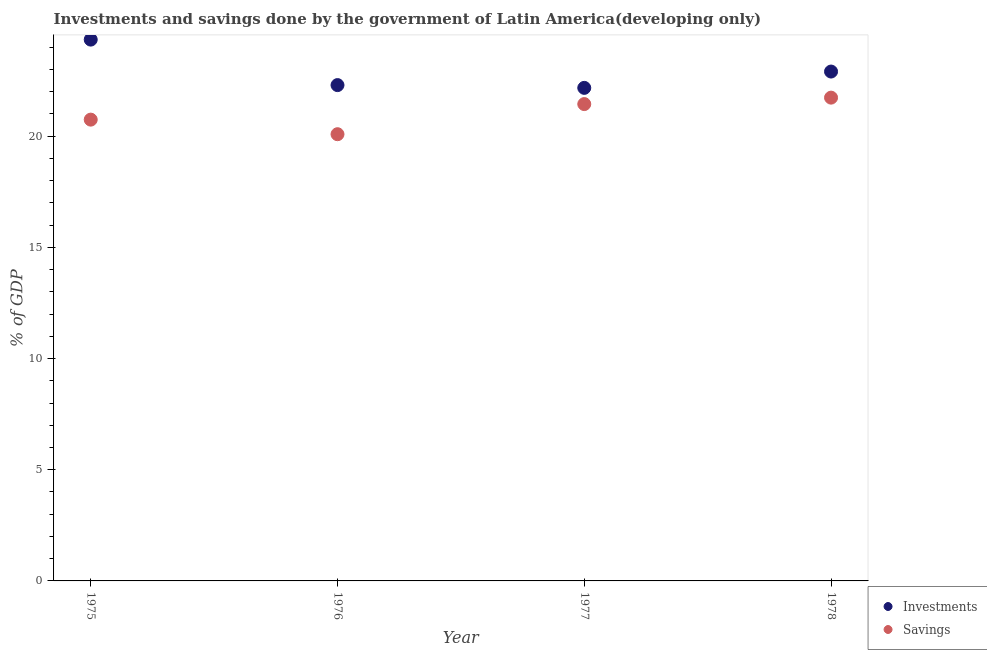Is the number of dotlines equal to the number of legend labels?
Ensure brevity in your answer.  Yes. What is the savings of government in 1978?
Offer a very short reply. 21.73. Across all years, what is the maximum investments of government?
Provide a succinct answer. 24.34. Across all years, what is the minimum savings of government?
Provide a short and direct response. 20.09. In which year was the savings of government maximum?
Your response must be concise. 1978. What is the total investments of government in the graph?
Offer a very short reply. 91.71. What is the difference between the investments of government in 1975 and that in 1977?
Your answer should be compact. 2.17. What is the difference between the savings of government in 1978 and the investments of government in 1976?
Keep it short and to the point. -0.56. What is the average savings of government per year?
Offer a terse response. 21. In the year 1975, what is the difference between the savings of government and investments of government?
Your answer should be very brief. -3.6. In how many years, is the savings of government greater than 1 %?
Offer a very short reply. 4. What is the ratio of the investments of government in 1976 to that in 1977?
Offer a very short reply. 1.01. Is the investments of government in 1975 less than that in 1976?
Keep it short and to the point. No. Is the difference between the savings of government in 1975 and 1976 greater than the difference between the investments of government in 1975 and 1976?
Provide a short and direct response. No. What is the difference between the highest and the second highest savings of government?
Offer a terse response. 0.29. What is the difference between the highest and the lowest savings of government?
Your response must be concise. 1.64. In how many years, is the investments of government greater than the average investments of government taken over all years?
Offer a terse response. 1. Is the sum of the investments of government in 1976 and 1977 greater than the maximum savings of government across all years?
Provide a succinct answer. Yes. Does the savings of government monotonically increase over the years?
Provide a short and direct response. No. What is the difference between two consecutive major ticks on the Y-axis?
Your response must be concise. 5. Does the graph contain grids?
Provide a short and direct response. No. Where does the legend appear in the graph?
Offer a very short reply. Bottom right. How many legend labels are there?
Provide a short and direct response. 2. How are the legend labels stacked?
Keep it short and to the point. Vertical. What is the title of the graph?
Give a very brief answer. Investments and savings done by the government of Latin America(developing only). Does "Investment in Transport" appear as one of the legend labels in the graph?
Your answer should be very brief. No. What is the label or title of the Y-axis?
Offer a terse response. % of GDP. What is the % of GDP in Investments in 1975?
Your answer should be very brief. 24.34. What is the % of GDP of Savings in 1975?
Make the answer very short. 20.74. What is the % of GDP in Investments in 1976?
Your answer should be compact. 22.3. What is the % of GDP of Savings in 1976?
Keep it short and to the point. 20.09. What is the % of GDP of Investments in 1977?
Offer a terse response. 22.17. What is the % of GDP of Savings in 1977?
Provide a short and direct response. 21.44. What is the % of GDP of Investments in 1978?
Provide a succinct answer. 22.9. What is the % of GDP of Savings in 1978?
Keep it short and to the point. 21.73. Across all years, what is the maximum % of GDP of Investments?
Your answer should be very brief. 24.34. Across all years, what is the maximum % of GDP of Savings?
Your response must be concise. 21.73. Across all years, what is the minimum % of GDP of Investments?
Give a very brief answer. 22.17. Across all years, what is the minimum % of GDP in Savings?
Your answer should be very brief. 20.09. What is the total % of GDP in Investments in the graph?
Provide a short and direct response. 91.71. What is the total % of GDP of Savings in the graph?
Your answer should be very brief. 84. What is the difference between the % of GDP of Investments in 1975 and that in 1976?
Keep it short and to the point. 2.05. What is the difference between the % of GDP of Savings in 1975 and that in 1976?
Your response must be concise. 0.66. What is the difference between the % of GDP of Investments in 1975 and that in 1977?
Your answer should be compact. 2.17. What is the difference between the % of GDP in Savings in 1975 and that in 1977?
Offer a terse response. -0.7. What is the difference between the % of GDP in Investments in 1975 and that in 1978?
Ensure brevity in your answer.  1.44. What is the difference between the % of GDP in Savings in 1975 and that in 1978?
Your answer should be compact. -0.99. What is the difference between the % of GDP of Investments in 1976 and that in 1977?
Give a very brief answer. 0.12. What is the difference between the % of GDP in Savings in 1976 and that in 1977?
Offer a very short reply. -1.35. What is the difference between the % of GDP of Investments in 1976 and that in 1978?
Make the answer very short. -0.61. What is the difference between the % of GDP of Savings in 1976 and that in 1978?
Provide a short and direct response. -1.64. What is the difference between the % of GDP of Investments in 1977 and that in 1978?
Provide a short and direct response. -0.73. What is the difference between the % of GDP of Savings in 1977 and that in 1978?
Provide a short and direct response. -0.29. What is the difference between the % of GDP in Investments in 1975 and the % of GDP in Savings in 1976?
Ensure brevity in your answer.  4.25. What is the difference between the % of GDP in Investments in 1975 and the % of GDP in Savings in 1977?
Ensure brevity in your answer.  2.9. What is the difference between the % of GDP of Investments in 1975 and the % of GDP of Savings in 1978?
Make the answer very short. 2.61. What is the difference between the % of GDP of Investments in 1976 and the % of GDP of Savings in 1977?
Ensure brevity in your answer.  0.85. What is the difference between the % of GDP in Investments in 1976 and the % of GDP in Savings in 1978?
Provide a short and direct response. 0.56. What is the difference between the % of GDP of Investments in 1977 and the % of GDP of Savings in 1978?
Your answer should be compact. 0.44. What is the average % of GDP of Investments per year?
Keep it short and to the point. 22.93. What is the average % of GDP of Savings per year?
Make the answer very short. 21. In the year 1975, what is the difference between the % of GDP of Investments and % of GDP of Savings?
Provide a short and direct response. 3.6. In the year 1976, what is the difference between the % of GDP in Investments and % of GDP in Savings?
Provide a succinct answer. 2.21. In the year 1977, what is the difference between the % of GDP of Investments and % of GDP of Savings?
Your answer should be compact. 0.73. In the year 1978, what is the difference between the % of GDP in Investments and % of GDP in Savings?
Make the answer very short. 1.17. What is the ratio of the % of GDP in Investments in 1975 to that in 1976?
Provide a succinct answer. 1.09. What is the ratio of the % of GDP in Savings in 1975 to that in 1976?
Provide a succinct answer. 1.03. What is the ratio of the % of GDP in Investments in 1975 to that in 1977?
Your response must be concise. 1.1. What is the ratio of the % of GDP in Savings in 1975 to that in 1977?
Offer a terse response. 0.97. What is the ratio of the % of GDP of Investments in 1975 to that in 1978?
Offer a very short reply. 1.06. What is the ratio of the % of GDP in Savings in 1975 to that in 1978?
Your answer should be compact. 0.95. What is the ratio of the % of GDP of Investments in 1976 to that in 1977?
Give a very brief answer. 1.01. What is the ratio of the % of GDP in Savings in 1976 to that in 1977?
Make the answer very short. 0.94. What is the ratio of the % of GDP of Investments in 1976 to that in 1978?
Give a very brief answer. 0.97. What is the ratio of the % of GDP of Savings in 1976 to that in 1978?
Provide a succinct answer. 0.92. What is the ratio of the % of GDP in Savings in 1977 to that in 1978?
Ensure brevity in your answer.  0.99. What is the difference between the highest and the second highest % of GDP in Investments?
Your answer should be very brief. 1.44. What is the difference between the highest and the second highest % of GDP of Savings?
Make the answer very short. 0.29. What is the difference between the highest and the lowest % of GDP in Investments?
Keep it short and to the point. 2.17. What is the difference between the highest and the lowest % of GDP in Savings?
Make the answer very short. 1.64. 